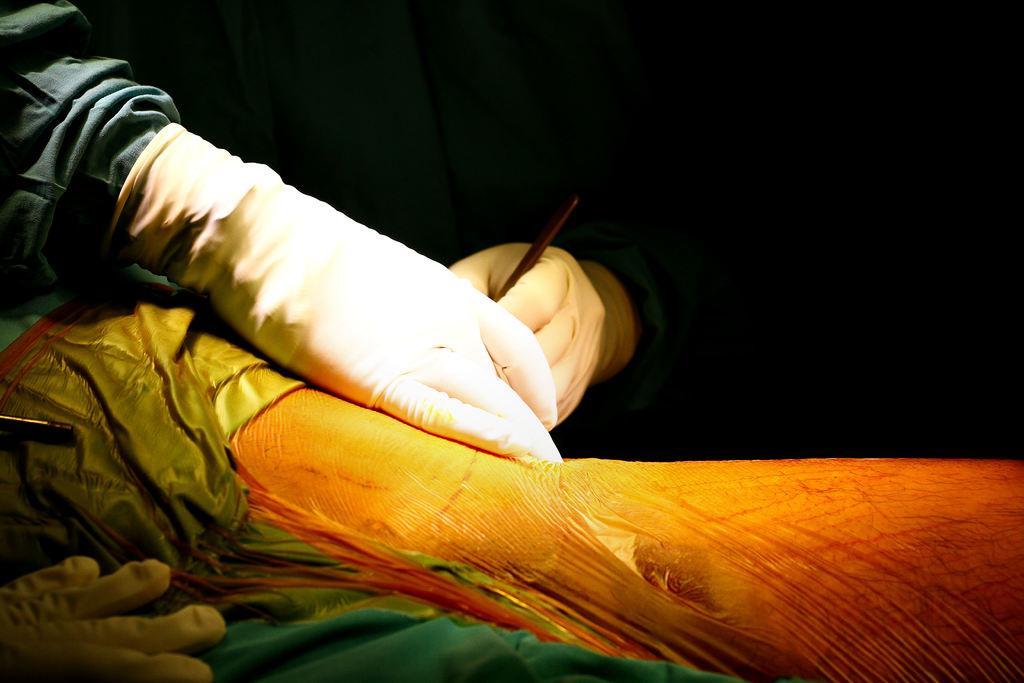Can you describe this image briefly? In this image there is one person who is wearing gloves and holding some stick, and he is doing something. At the bottom it looks like an animal, on the animal there is one cloth and there is black background. 